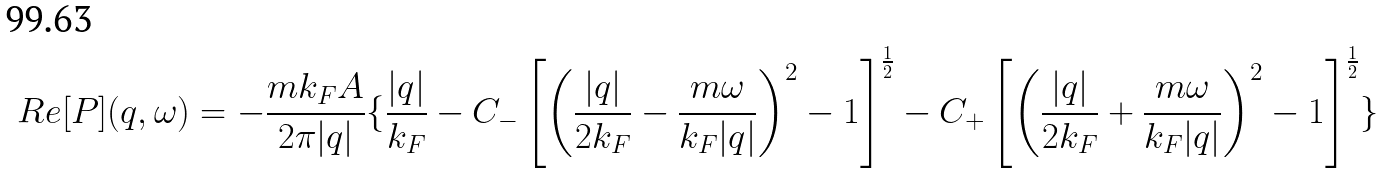Convert formula to latex. <formula><loc_0><loc_0><loc_500><loc_500>R e [ P ] ( { q } , \omega ) = - \frac { m k _ { F } A } { 2 \pi | { q } | } \{ \frac { | { q } | } { k _ { F } } - C _ { - } \left [ \left ( \frac { | { q } | } { 2 k _ { F } } - \frac { m \omega } { k _ { F } | { q } | } \right ) ^ { 2 } - 1 \right ] ^ { \frac { 1 } { 2 } } - C _ { + } \left [ \left ( \frac { | { q } | } { 2 k _ { F } } + \frac { m \omega } { k _ { F } | { q } | } \right ) ^ { 2 } - 1 \right ] ^ { \frac { 1 } { 2 } } \}</formula> 